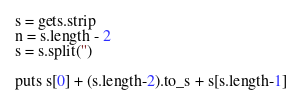Convert code to text. <code><loc_0><loc_0><loc_500><loc_500><_Ruby_>s = gets.strip
n = s.length - 2
s = s.split('')

puts s[0] + (s.length-2).to_s + s[s.length-1]</code> 